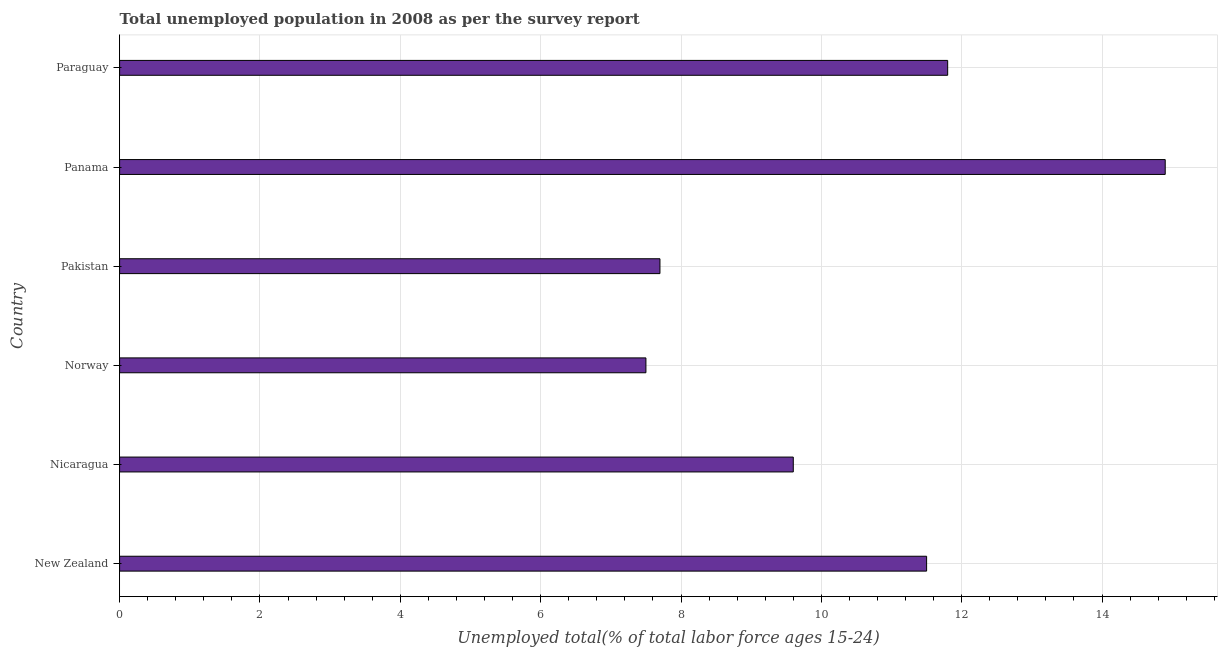What is the title of the graph?
Keep it short and to the point. Total unemployed population in 2008 as per the survey report. What is the label or title of the X-axis?
Offer a very short reply. Unemployed total(% of total labor force ages 15-24). What is the unemployed youth in Nicaragua?
Keep it short and to the point. 9.6. Across all countries, what is the maximum unemployed youth?
Your answer should be very brief. 14.9. Across all countries, what is the minimum unemployed youth?
Ensure brevity in your answer.  7.5. In which country was the unemployed youth maximum?
Provide a short and direct response. Panama. In which country was the unemployed youth minimum?
Provide a short and direct response. Norway. What is the sum of the unemployed youth?
Offer a very short reply. 63. What is the average unemployed youth per country?
Offer a terse response. 10.5. What is the median unemployed youth?
Give a very brief answer. 10.55. What is the ratio of the unemployed youth in Nicaragua to that in Paraguay?
Your answer should be very brief. 0.81. What is the difference between the highest and the second highest unemployed youth?
Ensure brevity in your answer.  3.1. Is the sum of the unemployed youth in Norway and Pakistan greater than the maximum unemployed youth across all countries?
Keep it short and to the point. Yes. What is the difference between the highest and the lowest unemployed youth?
Ensure brevity in your answer.  7.4. In how many countries, is the unemployed youth greater than the average unemployed youth taken over all countries?
Your answer should be very brief. 3. How many bars are there?
Your answer should be very brief. 6. How many countries are there in the graph?
Your response must be concise. 6. What is the difference between two consecutive major ticks on the X-axis?
Keep it short and to the point. 2. Are the values on the major ticks of X-axis written in scientific E-notation?
Keep it short and to the point. No. What is the Unemployed total(% of total labor force ages 15-24) of Nicaragua?
Keep it short and to the point. 9.6. What is the Unemployed total(% of total labor force ages 15-24) of Pakistan?
Your answer should be very brief. 7.7. What is the Unemployed total(% of total labor force ages 15-24) in Panama?
Make the answer very short. 14.9. What is the Unemployed total(% of total labor force ages 15-24) of Paraguay?
Keep it short and to the point. 11.8. What is the difference between the Unemployed total(% of total labor force ages 15-24) in New Zealand and Pakistan?
Your response must be concise. 3.8. What is the difference between the Unemployed total(% of total labor force ages 15-24) in New Zealand and Panama?
Ensure brevity in your answer.  -3.4. What is the difference between the Unemployed total(% of total labor force ages 15-24) in Nicaragua and Norway?
Make the answer very short. 2.1. What is the difference between the Unemployed total(% of total labor force ages 15-24) in Nicaragua and Pakistan?
Ensure brevity in your answer.  1.9. What is the difference between the Unemployed total(% of total labor force ages 15-24) in Nicaragua and Paraguay?
Make the answer very short. -2.2. What is the difference between the Unemployed total(% of total labor force ages 15-24) in Norway and Pakistan?
Make the answer very short. -0.2. What is the difference between the Unemployed total(% of total labor force ages 15-24) in Norway and Panama?
Make the answer very short. -7.4. What is the difference between the Unemployed total(% of total labor force ages 15-24) in Panama and Paraguay?
Make the answer very short. 3.1. What is the ratio of the Unemployed total(% of total labor force ages 15-24) in New Zealand to that in Nicaragua?
Give a very brief answer. 1.2. What is the ratio of the Unemployed total(% of total labor force ages 15-24) in New Zealand to that in Norway?
Your response must be concise. 1.53. What is the ratio of the Unemployed total(% of total labor force ages 15-24) in New Zealand to that in Pakistan?
Your answer should be compact. 1.49. What is the ratio of the Unemployed total(% of total labor force ages 15-24) in New Zealand to that in Panama?
Give a very brief answer. 0.77. What is the ratio of the Unemployed total(% of total labor force ages 15-24) in New Zealand to that in Paraguay?
Provide a short and direct response. 0.97. What is the ratio of the Unemployed total(% of total labor force ages 15-24) in Nicaragua to that in Norway?
Provide a succinct answer. 1.28. What is the ratio of the Unemployed total(% of total labor force ages 15-24) in Nicaragua to that in Pakistan?
Give a very brief answer. 1.25. What is the ratio of the Unemployed total(% of total labor force ages 15-24) in Nicaragua to that in Panama?
Your response must be concise. 0.64. What is the ratio of the Unemployed total(% of total labor force ages 15-24) in Nicaragua to that in Paraguay?
Offer a terse response. 0.81. What is the ratio of the Unemployed total(% of total labor force ages 15-24) in Norway to that in Pakistan?
Provide a short and direct response. 0.97. What is the ratio of the Unemployed total(% of total labor force ages 15-24) in Norway to that in Panama?
Provide a succinct answer. 0.5. What is the ratio of the Unemployed total(% of total labor force ages 15-24) in Norway to that in Paraguay?
Offer a terse response. 0.64. What is the ratio of the Unemployed total(% of total labor force ages 15-24) in Pakistan to that in Panama?
Offer a very short reply. 0.52. What is the ratio of the Unemployed total(% of total labor force ages 15-24) in Pakistan to that in Paraguay?
Your response must be concise. 0.65. What is the ratio of the Unemployed total(% of total labor force ages 15-24) in Panama to that in Paraguay?
Make the answer very short. 1.26. 